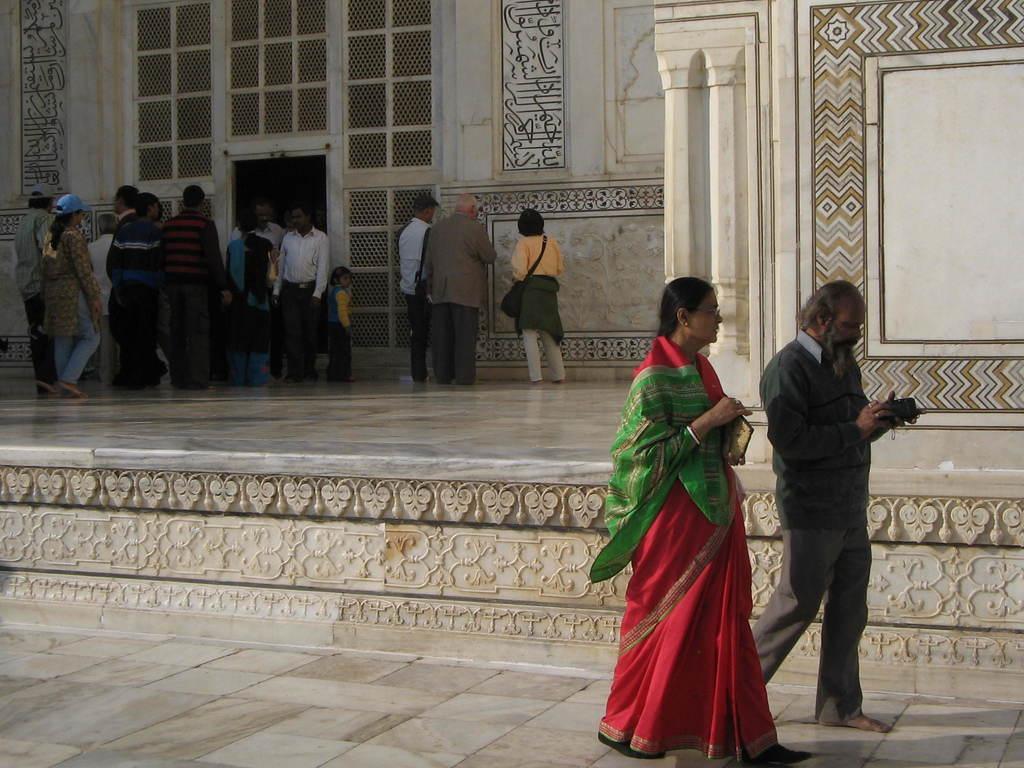Describe this image in one or two sentences. In this image on the right side two persons are walking on the tiles and holding objects in their hands. In the background we can see a building, few persons are standing on the floor and there are designs on the wall. 